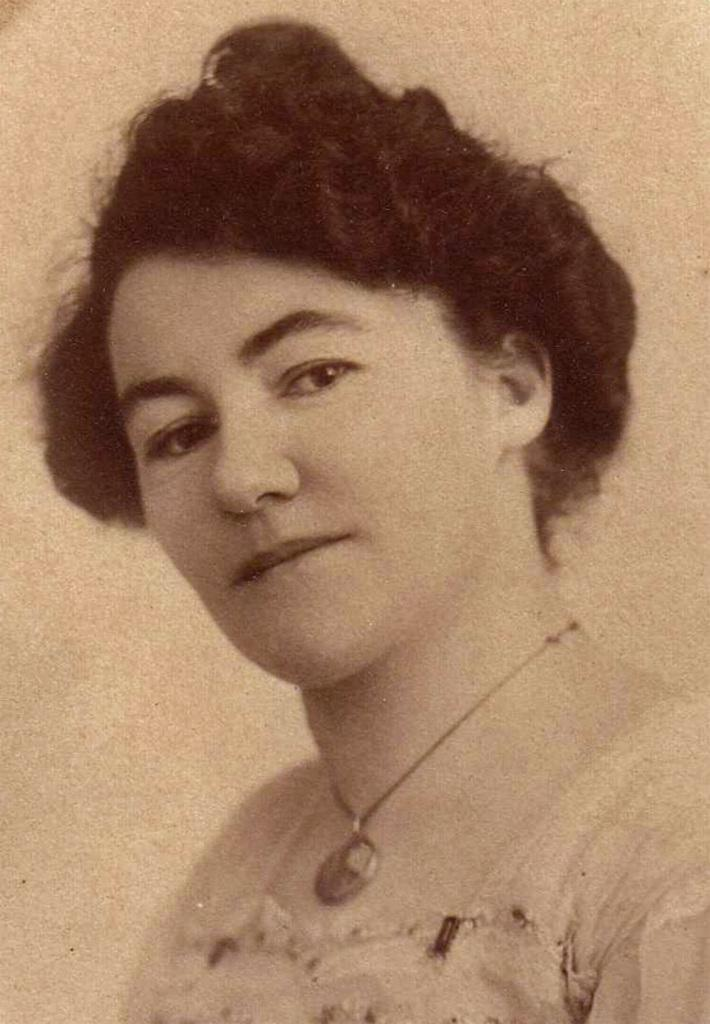Who is the main subject in the image? There is a lady in the image. What is the lady wearing in the image? The lady is wearing a chain with a pendant. How many sisters does the lady have in the image? There is no information about the lady's sisters in the image. What type of carpenter tool can be seen in the image? There are no carpenter tools present in the image. 